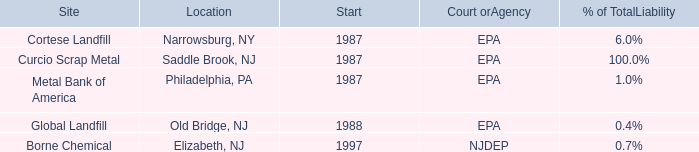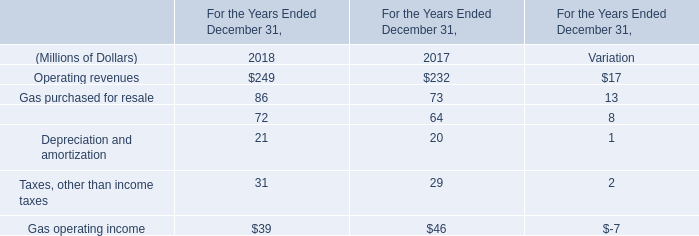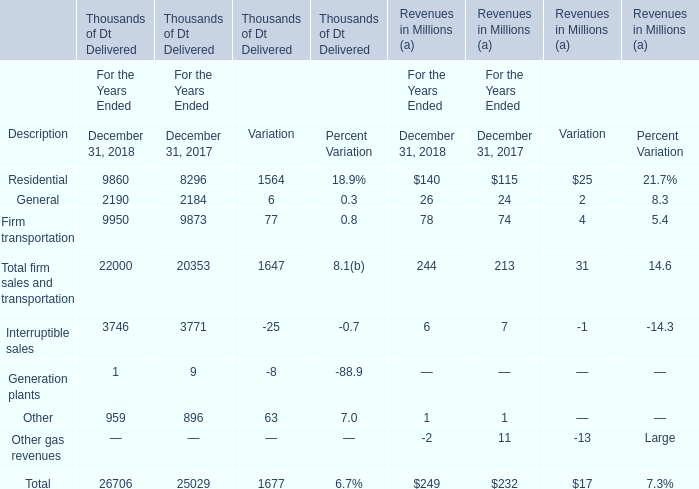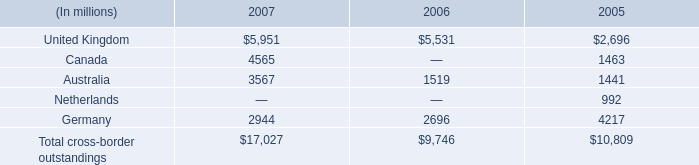what was the value of the company's consolidated total assets , in millions of dollars , as of december 31 , 2007? 
Computations: (17027 / 12%)
Answer: 141891.66667. 